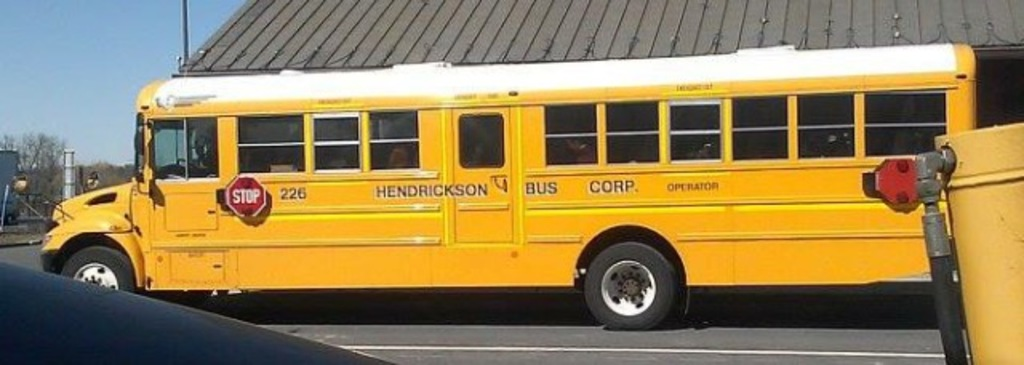How does the condition of the bus reflect on its maintenance? The bus appears well-maintained with a clean and bright yellow exterior, clear windows, and no visible damage, indicating that it is likely kept in good running condition by Henderson Bus Corp. 